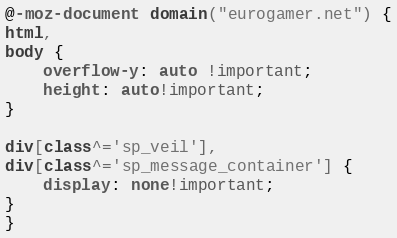<code> <loc_0><loc_0><loc_500><loc_500><_CSS_>@-moz-document domain("eurogamer.net") {
html,
body {
    overflow-y: auto !important;
    height: auto!important;
}

div[class^='sp_veil'],
div[class^='sp_message_container'] {
    display: none!important;
}
}
</code> 